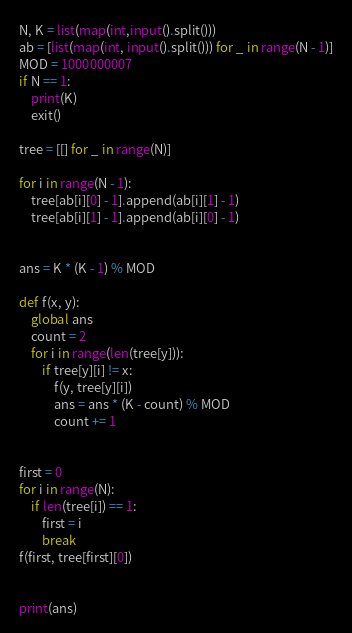<code> <loc_0><loc_0><loc_500><loc_500><_Python_>N, K = list(map(int,input().split()))
ab = [list(map(int, input().split())) for _ in range(N - 1)]
MOD = 1000000007
if N == 1:
    print(K)
    exit()

tree = [[] for _ in range(N)]

for i in range(N - 1):
    tree[ab[i][0] - 1].append(ab[i][1] - 1)
    tree[ab[i][1] - 1].append(ab[i][0] - 1)


ans = K * (K - 1) % MOD

def f(x, y):
    global ans
    count = 2
    for i in range(len(tree[y])):
        if tree[y][i] != x:
            f(y, tree[y][i])
            ans = ans * (K - count) % MOD
            count += 1


first = 0
for i in range(N):
    if len(tree[i]) == 1:
        first = i
        break
f(first, tree[first][0])


print(ans)

</code> 